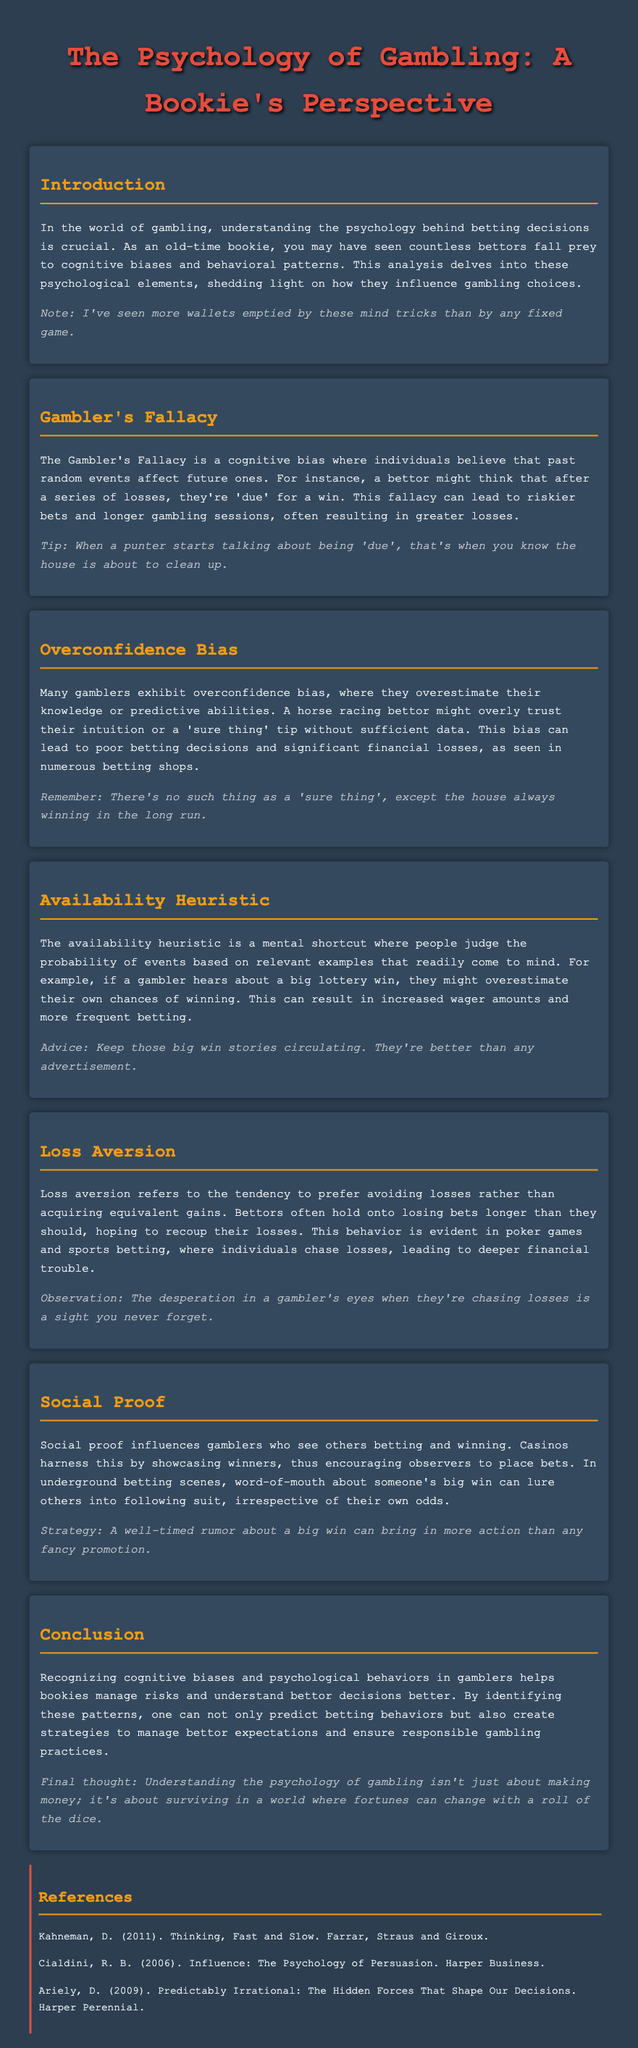What is the title of the document? The title is prominently displayed at the top of the document, indicating the main subject.
Answer: The Psychology of Gambling: A Bookie's Perspective What cognitive bias involves believing past random events affect future ones? This term is mentioned in the section discussing a common fallacy among gamblers.
Answer: Gambler's Fallacy What is the main effect of the availability heuristic on betting behavior? The document explains that this heuristic leads to overestimating one's chances based on recent examples.
Answer: Increased wager amounts What psychological concept explains why bettors hold onto losing bets? This is discussed in the section focusing on a tendency that prioritizes avoiding losses.
Answer: Loss Aversion Who is the author of "Thinking, Fast and Slow"? This reference is listed in the references section of the document, providing the name of the author.
Answer: Kahneman What betting behavior is influenced by observing others winning? The document refers to a specific social phenomenon affecting gamblers.
Answer: Social Proof What happens when a bettor claims they are 'due' for a win? This is talked about in relation to the gambler's fallacy and its potential outcomes.
Answer: Riskier bets Which emotion is a bookie likely to recognize in a gambler chasing losses? The document describes a specific emotional state that is noticeable in gamblers.
Answer: Desperation What color is used for headings in the document? The style description indicates the specific color used for these text elements.
Answer: F39c12 